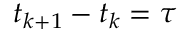Convert formula to latex. <formula><loc_0><loc_0><loc_500><loc_500>t _ { k + 1 } - t _ { k } = \tau</formula> 